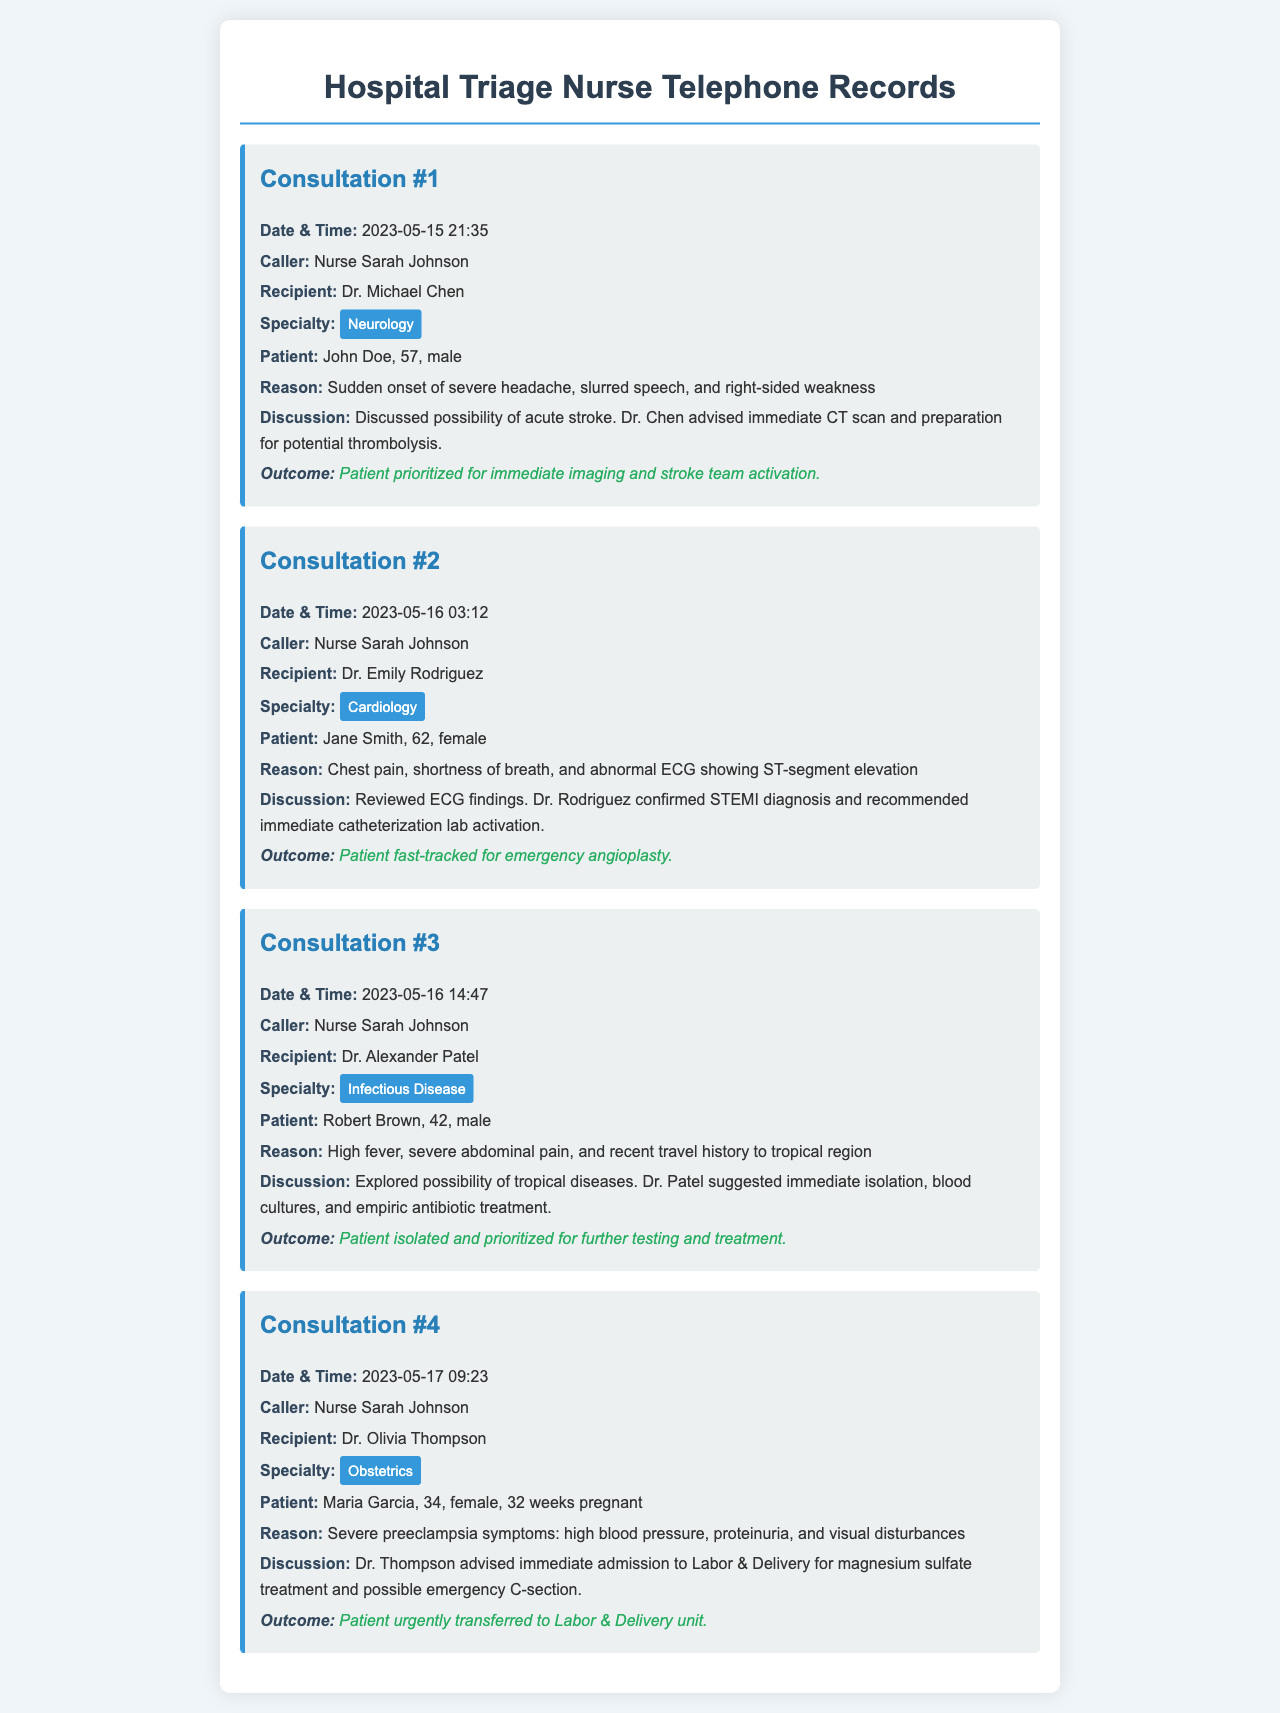what is the specialty of the first consultation? The specialty of the first consultation is mentioned as Neurology.
Answer: Neurology who was the recipient of the second consultation? The recipient in the second consultation is Dr. Emily Rodriguez.
Answer: Dr. Emily Rodriguez what was the reason for Robert Brown's consultation? The reason for Robert Brown's consultation was high fever, severe abdominal pain, and recent travel history to tropical region.
Answer: High fever, severe abdominal pain, and recent travel history to tropical region what is the outcome of Maria Garcia's consultation? The outcome for Maria Garcia is that she was urgently transferred to the Labor & Delivery unit.
Answer: Urgently transferred to Labor & Delivery unit how many consultations were conducted on May 16? There were two consultations conducted on May 16.
Answer: 2 which patient was discussed at 21:35 on May 15? The patient discussed at 21:35 on May 15 was John Doe.
Answer: John Doe what immediate treatment was advised for Jane Smith? The immediate treatment advised for Jane Smith was emergency angioplasty.
Answer: Emergency angioplasty who called in for the consultation regarding severe preeclampsia? Nurse Sarah Johnson called in for the consultation regarding severe preeclampsia.
Answer: Nurse Sarah Johnson 